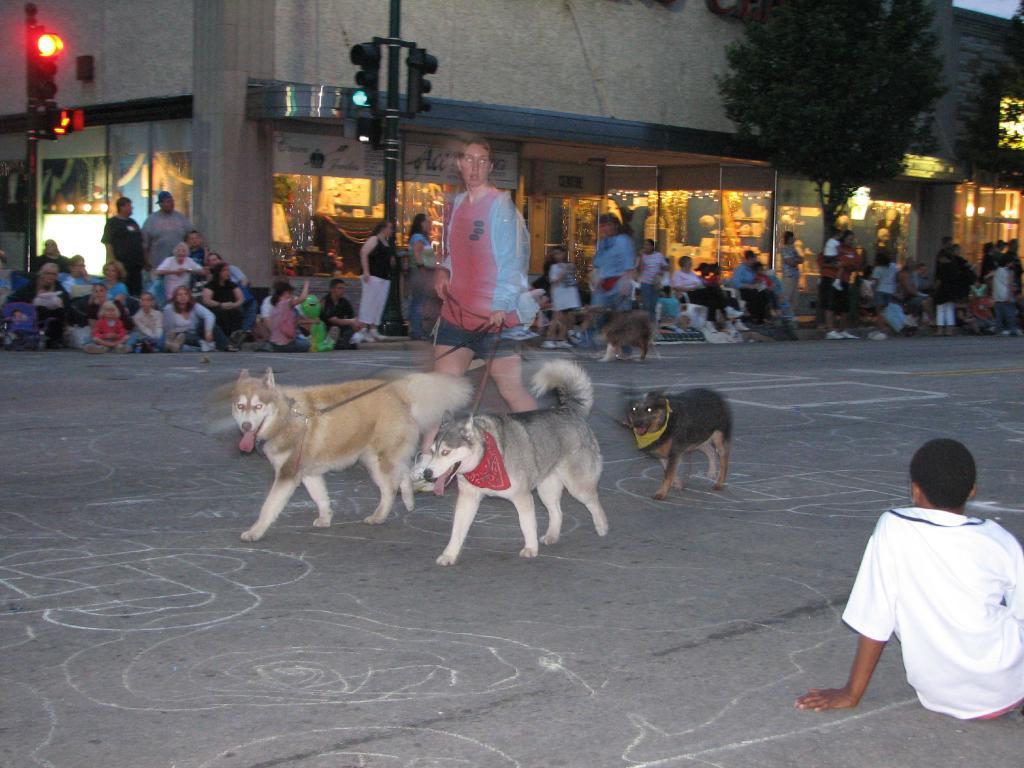Please provide a concise description of this image. The woman in pink T-shirt and blue jacket is walking with the three dogs. Behind her, we see people sitting on the road. Beside them, there are traffic signals. Behind them, we see a building and trees. At the bottom of the picture, we see the road. This picture is clicked outside the city. 